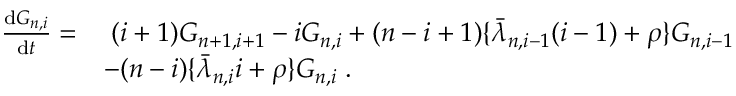Convert formula to latex. <formula><loc_0><loc_0><loc_500><loc_500>\begin{array} { r l } { \frac { d G _ { n , i } } { d t } = } & { \, ( i + 1 ) G _ { n + 1 , i + 1 } - i G _ { n , i } + ( n - i + 1 ) \{ \bar { \lambda } _ { n , i - 1 } ( i - 1 ) + \rho \} G _ { n , i - 1 } } \\ & { - ( n - i ) \{ \bar { \lambda } _ { n , i } i + \rho \} G _ { n , i } \, . } \end{array}</formula> 